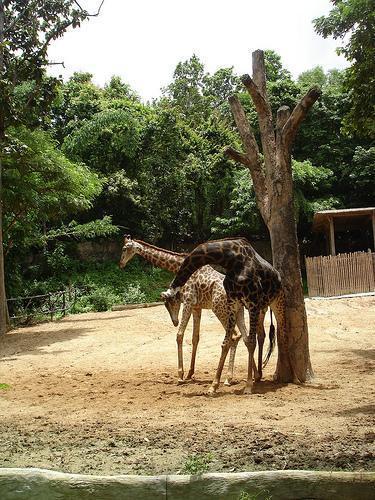How many giraffes are there?
Give a very brief answer. 2. How many giraffes are there?
Give a very brief answer. 2. 